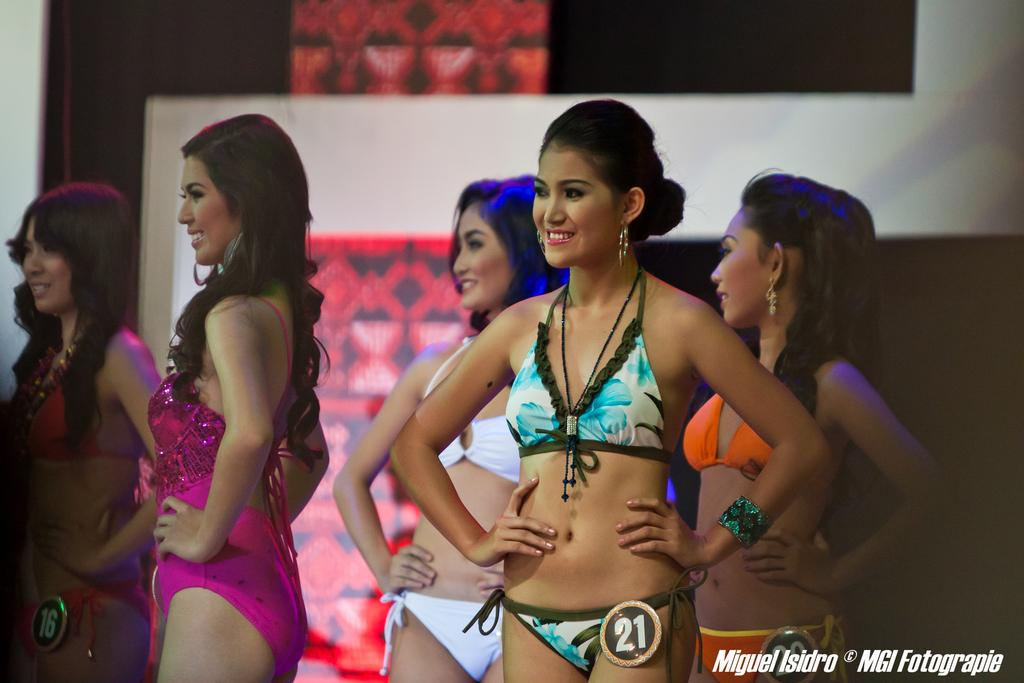What are the people in the image doing? The people in the image are standing and smiling. Can you describe the text at the bottom of the image? Unfortunately, the text at the bottom of the image cannot be read or described without more information. What is visible in the background of the image? There is a wall with images in the background of the image. What is the tendency of the brake in the image? There is no brake present in the image, so it is not possible to determine its tendency. 